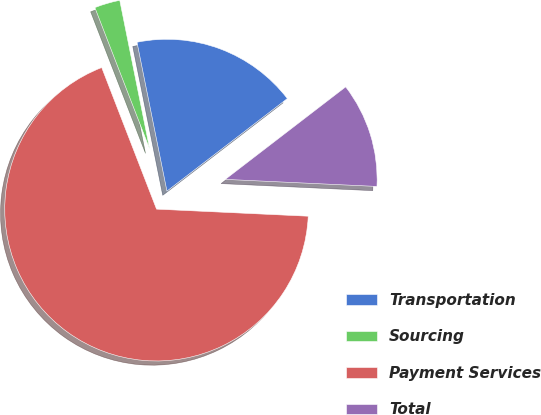<chart> <loc_0><loc_0><loc_500><loc_500><pie_chart><fcel>Transportation<fcel>Sourcing<fcel>Payment Services<fcel>Total<nl><fcel>17.73%<fcel>2.72%<fcel>68.37%<fcel>11.17%<nl></chart> 